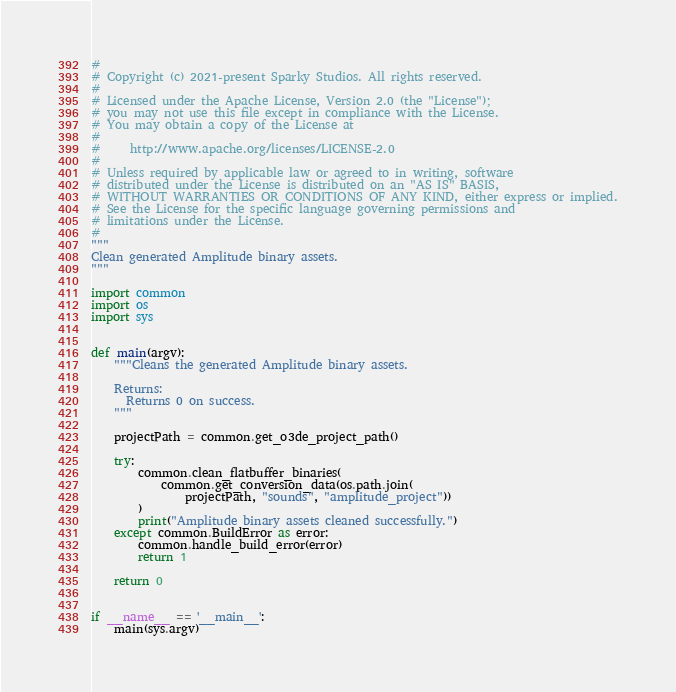<code> <loc_0><loc_0><loc_500><loc_500><_Python_>#
# Copyright (c) 2021-present Sparky Studios. All rights reserved.
#
# Licensed under the Apache License, Version 2.0 (the "License");
# you may not use this file except in compliance with the License.
# You may obtain a copy of the License at
#
#     http://www.apache.org/licenses/LICENSE-2.0
#
# Unless required by applicable law or agreed to in writing, software
# distributed under the License is distributed on an "AS IS" BASIS,
# WITHOUT WARRANTIES OR CONDITIONS OF ANY KIND, either express or implied.
# See the License for the specific language governing permissions and
# limitations under the License.
#
"""
Clean generated Amplitude binary assets.
"""

import common
import os
import sys


def main(argv):
    """Cleans the generated Amplitude binary assets.

    Returns:
      Returns 0 on success.
    """

    projectPath = common.get_o3de_project_path()

    try:
        common.clean_flatbuffer_binaries(
            common.get_conversion_data(os.path.join(
                projectPath, "sounds", "amplitude_project"))
        )
        print("Amplitude binary assets cleaned successfully.")
    except common.BuildError as error:
        common.handle_build_error(error)
        return 1

    return 0


if __name__ == '__main__':
    main(sys.argv)
</code> 